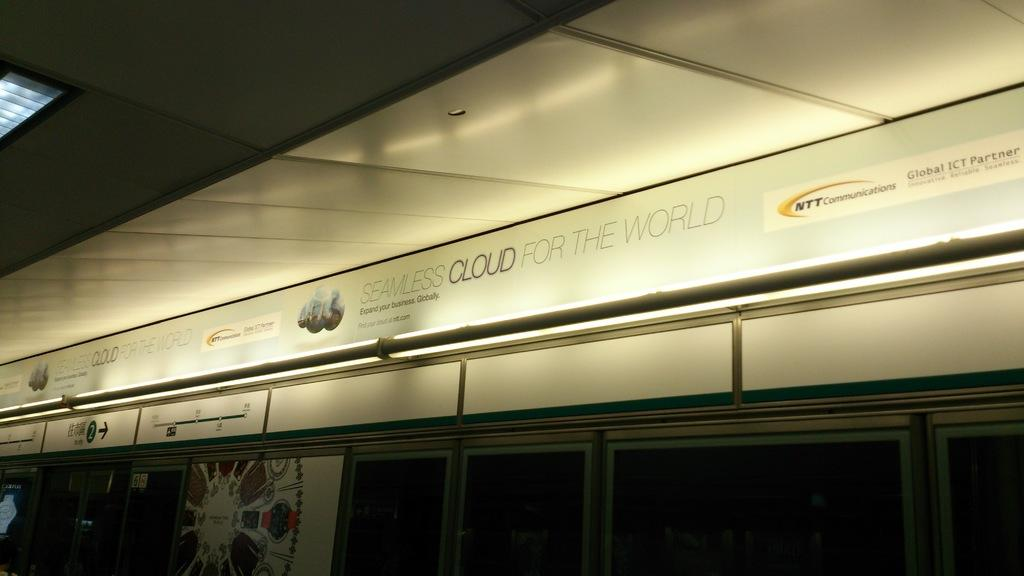What is the main structure visible in the image? There is a building in the image. Can you describe any additional features on the building? Yes, there is text on the building. What type of ornament is hanging from the card in the image? There is no card or ornament present in the image. What kind of brush is being used to paint the building in the image? The image is a photograph, not a painting, so there is no brush present. 